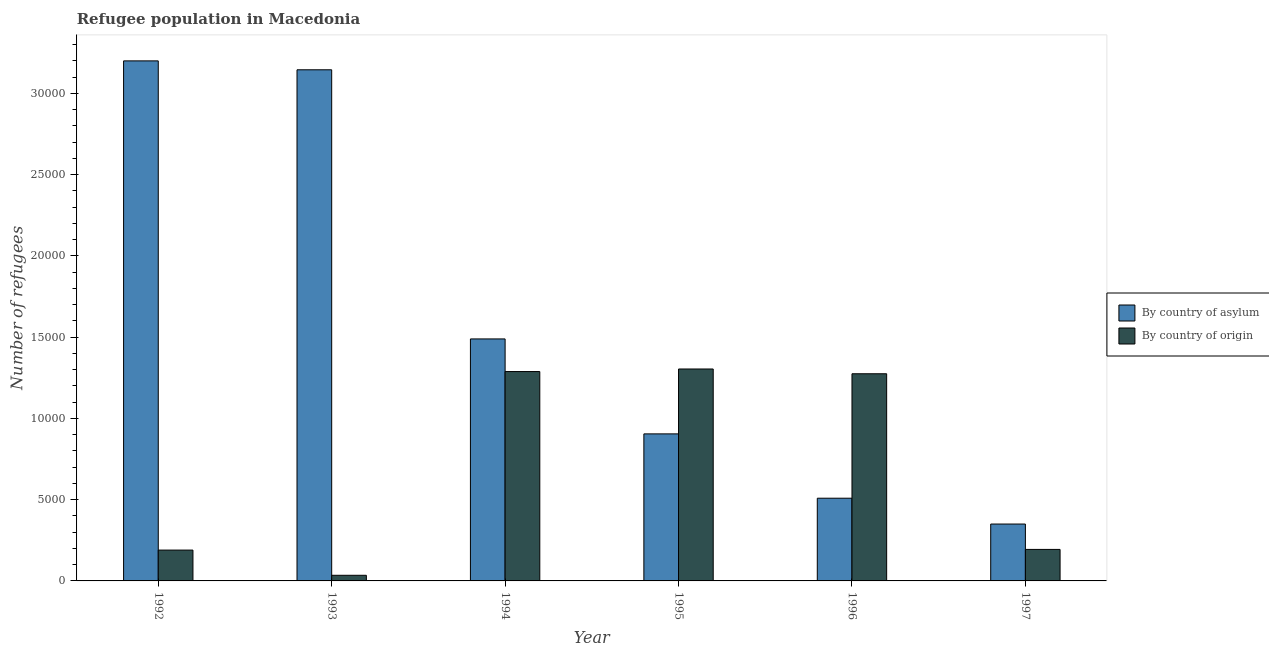How many groups of bars are there?
Ensure brevity in your answer.  6. How many bars are there on the 1st tick from the left?
Your response must be concise. 2. In how many cases, is the number of bars for a given year not equal to the number of legend labels?
Make the answer very short. 0. What is the number of refugees by country of asylum in 1997?
Your answer should be very brief. 3500. Across all years, what is the maximum number of refugees by country of asylum?
Your answer should be very brief. 3.20e+04. Across all years, what is the minimum number of refugees by country of asylum?
Your response must be concise. 3500. In which year was the number of refugees by country of origin maximum?
Your response must be concise. 1995. What is the total number of refugees by country of asylum in the graph?
Your answer should be very brief. 9.60e+04. What is the difference between the number of refugees by country of asylum in 1994 and that in 1995?
Make the answer very short. 5843. What is the difference between the number of refugees by country of origin in 1997 and the number of refugees by country of asylum in 1993?
Ensure brevity in your answer.  1592. What is the average number of refugees by country of asylum per year?
Ensure brevity in your answer.  1.60e+04. In the year 1994, what is the difference between the number of refugees by country of origin and number of refugees by country of asylum?
Make the answer very short. 0. What is the ratio of the number of refugees by country of asylum in 1992 to that in 1994?
Make the answer very short. 2.15. What is the difference between the highest and the second highest number of refugees by country of asylum?
Provide a short and direct response. 548. What is the difference between the highest and the lowest number of refugees by country of asylum?
Provide a short and direct response. 2.85e+04. In how many years, is the number of refugees by country of origin greater than the average number of refugees by country of origin taken over all years?
Your answer should be very brief. 3. Is the sum of the number of refugees by country of origin in 1992 and 1993 greater than the maximum number of refugees by country of asylum across all years?
Your response must be concise. No. What does the 1st bar from the left in 1993 represents?
Give a very brief answer. By country of asylum. What does the 2nd bar from the right in 1996 represents?
Offer a very short reply. By country of asylum. What is the difference between two consecutive major ticks on the Y-axis?
Your answer should be very brief. 5000. Are the values on the major ticks of Y-axis written in scientific E-notation?
Offer a terse response. No. Does the graph contain any zero values?
Your answer should be very brief. No. Does the graph contain grids?
Ensure brevity in your answer.  No. Where does the legend appear in the graph?
Provide a short and direct response. Center right. How many legend labels are there?
Provide a short and direct response. 2. What is the title of the graph?
Provide a short and direct response. Refugee population in Macedonia. What is the label or title of the X-axis?
Ensure brevity in your answer.  Year. What is the label or title of the Y-axis?
Give a very brief answer. Number of refugees. What is the Number of refugees in By country of asylum in 1992?
Keep it short and to the point. 3.20e+04. What is the Number of refugees in By country of origin in 1992?
Provide a short and direct response. 1897. What is the Number of refugees of By country of asylum in 1993?
Make the answer very short. 3.15e+04. What is the Number of refugees of By country of origin in 1993?
Provide a succinct answer. 347. What is the Number of refugees in By country of asylum in 1994?
Ensure brevity in your answer.  1.49e+04. What is the Number of refugees of By country of origin in 1994?
Ensure brevity in your answer.  1.29e+04. What is the Number of refugees in By country of asylum in 1995?
Ensure brevity in your answer.  9048. What is the Number of refugees of By country of origin in 1995?
Your answer should be very brief. 1.30e+04. What is the Number of refugees in By country of asylum in 1996?
Provide a short and direct response. 5089. What is the Number of refugees of By country of origin in 1996?
Offer a terse response. 1.27e+04. What is the Number of refugees of By country of asylum in 1997?
Your answer should be compact. 3500. What is the Number of refugees in By country of origin in 1997?
Provide a succinct answer. 1939. Across all years, what is the maximum Number of refugees of By country of asylum?
Make the answer very short. 3.20e+04. Across all years, what is the maximum Number of refugees of By country of origin?
Your answer should be compact. 1.30e+04. Across all years, what is the minimum Number of refugees of By country of asylum?
Offer a very short reply. 3500. Across all years, what is the minimum Number of refugees in By country of origin?
Keep it short and to the point. 347. What is the total Number of refugees in By country of asylum in the graph?
Your answer should be compact. 9.60e+04. What is the total Number of refugees in By country of origin in the graph?
Offer a very short reply. 4.29e+04. What is the difference between the Number of refugees in By country of asylum in 1992 and that in 1993?
Your response must be concise. 548. What is the difference between the Number of refugees in By country of origin in 1992 and that in 1993?
Ensure brevity in your answer.  1550. What is the difference between the Number of refugees of By country of asylum in 1992 and that in 1994?
Keep it short and to the point. 1.71e+04. What is the difference between the Number of refugees in By country of origin in 1992 and that in 1994?
Your answer should be very brief. -1.10e+04. What is the difference between the Number of refugees in By country of asylum in 1992 and that in 1995?
Keep it short and to the point. 2.30e+04. What is the difference between the Number of refugees of By country of origin in 1992 and that in 1995?
Make the answer very short. -1.11e+04. What is the difference between the Number of refugees in By country of asylum in 1992 and that in 1996?
Offer a terse response. 2.69e+04. What is the difference between the Number of refugees of By country of origin in 1992 and that in 1996?
Offer a terse response. -1.08e+04. What is the difference between the Number of refugees in By country of asylum in 1992 and that in 1997?
Offer a very short reply. 2.85e+04. What is the difference between the Number of refugees in By country of origin in 1992 and that in 1997?
Your answer should be compact. -42. What is the difference between the Number of refugees of By country of asylum in 1993 and that in 1994?
Offer a very short reply. 1.66e+04. What is the difference between the Number of refugees in By country of origin in 1993 and that in 1994?
Your response must be concise. -1.25e+04. What is the difference between the Number of refugees of By country of asylum in 1993 and that in 1995?
Give a very brief answer. 2.24e+04. What is the difference between the Number of refugees in By country of origin in 1993 and that in 1995?
Keep it short and to the point. -1.27e+04. What is the difference between the Number of refugees of By country of asylum in 1993 and that in 1996?
Your answer should be compact. 2.64e+04. What is the difference between the Number of refugees in By country of origin in 1993 and that in 1996?
Your response must be concise. -1.24e+04. What is the difference between the Number of refugees of By country of asylum in 1993 and that in 1997?
Give a very brief answer. 2.80e+04. What is the difference between the Number of refugees in By country of origin in 1993 and that in 1997?
Keep it short and to the point. -1592. What is the difference between the Number of refugees in By country of asylum in 1994 and that in 1995?
Offer a very short reply. 5843. What is the difference between the Number of refugees of By country of origin in 1994 and that in 1995?
Give a very brief answer. -158. What is the difference between the Number of refugees in By country of asylum in 1994 and that in 1996?
Keep it short and to the point. 9802. What is the difference between the Number of refugees of By country of origin in 1994 and that in 1996?
Offer a very short reply. 136. What is the difference between the Number of refugees in By country of asylum in 1994 and that in 1997?
Provide a succinct answer. 1.14e+04. What is the difference between the Number of refugees in By country of origin in 1994 and that in 1997?
Offer a very short reply. 1.09e+04. What is the difference between the Number of refugees of By country of asylum in 1995 and that in 1996?
Provide a short and direct response. 3959. What is the difference between the Number of refugees of By country of origin in 1995 and that in 1996?
Keep it short and to the point. 294. What is the difference between the Number of refugees in By country of asylum in 1995 and that in 1997?
Your response must be concise. 5548. What is the difference between the Number of refugees in By country of origin in 1995 and that in 1997?
Ensure brevity in your answer.  1.11e+04. What is the difference between the Number of refugees in By country of asylum in 1996 and that in 1997?
Make the answer very short. 1589. What is the difference between the Number of refugees in By country of origin in 1996 and that in 1997?
Make the answer very short. 1.08e+04. What is the difference between the Number of refugees of By country of asylum in 1992 and the Number of refugees of By country of origin in 1993?
Keep it short and to the point. 3.17e+04. What is the difference between the Number of refugees in By country of asylum in 1992 and the Number of refugees in By country of origin in 1994?
Give a very brief answer. 1.91e+04. What is the difference between the Number of refugees in By country of asylum in 1992 and the Number of refugees in By country of origin in 1995?
Ensure brevity in your answer.  1.90e+04. What is the difference between the Number of refugees in By country of asylum in 1992 and the Number of refugees in By country of origin in 1996?
Your response must be concise. 1.93e+04. What is the difference between the Number of refugees of By country of asylum in 1992 and the Number of refugees of By country of origin in 1997?
Provide a short and direct response. 3.01e+04. What is the difference between the Number of refugees of By country of asylum in 1993 and the Number of refugees of By country of origin in 1994?
Make the answer very short. 1.86e+04. What is the difference between the Number of refugees of By country of asylum in 1993 and the Number of refugees of By country of origin in 1995?
Provide a short and direct response. 1.84e+04. What is the difference between the Number of refugees in By country of asylum in 1993 and the Number of refugees in By country of origin in 1996?
Keep it short and to the point. 1.87e+04. What is the difference between the Number of refugees in By country of asylum in 1993 and the Number of refugees in By country of origin in 1997?
Your response must be concise. 2.95e+04. What is the difference between the Number of refugees in By country of asylum in 1994 and the Number of refugees in By country of origin in 1995?
Make the answer very short. 1850. What is the difference between the Number of refugees in By country of asylum in 1994 and the Number of refugees in By country of origin in 1996?
Ensure brevity in your answer.  2144. What is the difference between the Number of refugees of By country of asylum in 1994 and the Number of refugees of By country of origin in 1997?
Your answer should be compact. 1.30e+04. What is the difference between the Number of refugees in By country of asylum in 1995 and the Number of refugees in By country of origin in 1996?
Your response must be concise. -3699. What is the difference between the Number of refugees of By country of asylum in 1995 and the Number of refugees of By country of origin in 1997?
Ensure brevity in your answer.  7109. What is the difference between the Number of refugees of By country of asylum in 1996 and the Number of refugees of By country of origin in 1997?
Your answer should be compact. 3150. What is the average Number of refugees in By country of asylum per year?
Provide a succinct answer. 1.60e+04. What is the average Number of refugees of By country of origin per year?
Provide a short and direct response. 7142.33. In the year 1992, what is the difference between the Number of refugees in By country of asylum and Number of refugees in By country of origin?
Provide a short and direct response. 3.01e+04. In the year 1993, what is the difference between the Number of refugees of By country of asylum and Number of refugees of By country of origin?
Offer a very short reply. 3.11e+04. In the year 1994, what is the difference between the Number of refugees in By country of asylum and Number of refugees in By country of origin?
Provide a succinct answer. 2008. In the year 1995, what is the difference between the Number of refugees in By country of asylum and Number of refugees in By country of origin?
Make the answer very short. -3993. In the year 1996, what is the difference between the Number of refugees of By country of asylum and Number of refugees of By country of origin?
Keep it short and to the point. -7658. In the year 1997, what is the difference between the Number of refugees of By country of asylum and Number of refugees of By country of origin?
Ensure brevity in your answer.  1561. What is the ratio of the Number of refugees of By country of asylum in 1992 to that in 1993?
Your response must be concise. 1.02. What is the ratio of the Number of refugees of By country of origin in 1992 to that in 1993?
Offer a terse response. 5.47. What is the ratio of the Number of refugees of By country of asylum in 1992 to that in 1994?
Your answer should be compact. 2.15. What is the ratio of the Number of refugees in By country of origin in 1992 to that in 1994?
Give a very brief answer. 0.15. What is the ratio of the Number of refugees in By country of asylum in 1992 to that in 1995?
Your response must be concise. 3.54. What is the ratio of the Number of refugees of By country of origin in 1992 to that in 1995?
Provide a succinct answer. 0.15. What is the ratio of the Number of refugees of By country of asylum in 1992 to that in 1996?
Keep it short and to the point. 6.29. What is the ratio of the Number of refugees in By country of origin in 1992 to that in 1996?
Your answer should be very brief. 0.15. What is the ratio of the Number of refugees in By country of asylum in 1992 to that in 1997?
Your response must be concise. 9.14. What is the ratio of the Number of refugees of By country of origin in 1992 to that in 1997?
Provide a short and direct response. 0.98. What is the ratio of the Number of refugees of By country of asylum in 1993 to that in 1994?
Provide a succinct answer. 2.11. What is the ratio of the Number of refugees in By country of origin in 1993 to that in 1994?
Your answer should be compact. 0.03. What is the ratio of the Number of refugees in By country of asylum in 1993 to that in 1995?
Keep it short and to the point. 3.48. What is the ratio of the Number of refugees in By country of origin in 1993 to that in 1995?
Give a very brief answer. 0.03. What is the ratio of the Number of refugees in By country of asylum in 1993 to that in 1996?
Offer a very short reply. 6.18. What is the ratio of the Number of refugees in By country of origin in 1993 to that in 1996?
Provide a succinct answer. 0.03. What is the ratio of the Number of refugees of By country of asylum in 1993 to that in 1997?
Provide a succinct answer. 8.99. What is the ratio of the Number of refugees of By country of origin in 1993 to that in 1997?
Give a very brief answer. 0.18. What is the ratio of the Number of refugees of By country of asylum in 1994 to that in 1995?
Keep it short and to the point. 1.65. What is the ratio of the Number of refugees in By country of origin in 1994 to that in 1995?
Offer a very short reply. 0.99. What is the ratio of the Number of refugees in By country of asylum in 1994 to that in 1996?
Your answer should be compact. 2.93. What is the ratio of the Number of refugees of By country of origin in 1994 to that in 1996?
Make the answer very short. 1.01. What is the ratio of the Number of refugees of By country of asylum in 1994 to that in 1997?
Offer a terse response. 4.25. What is the ratio of the Number of refugees in By country of origin in 1994 to that in 1997?
Provide a succinct answer. 6.64. What is the ratio of the Number of refugees in By country of asylum in 1995 to that in 1996?
Provide a succinct answer. 1.78. What is the ratio of the Number of refugees of By country of origin in 1995 to that in 1996?
Provide a succinct answer. 1.02. What is the ratio of the Number of refugees of By country of asylum in 1995 to that in 1997?
Offer a very short reply. 2.59. What is the ratio of the Number of refugees of By country of origin in 1995 to that in 1997?
Your answer should be very brief. 6.73. What is the ratio of the Number of refugees in By country of asylum in 1996 to that in 1997?
Offer a terse response. 1.45. What is the ratio of the Number of refugees of By country of origin in 1996 to that in 1997?
Ensure brevity in your answer.  6.57. What is the difference between the highest and the second highest Number of refugees in By country of asylum?
Offer a terse response. 548. What is the difference between the highest and the second highest Number of refugees in By country of origin?
Your response must be concise. 158. What is the difference between the highest and the lowest Number of refugees in By country of asylum?
Your response must be concise. 2.85e+04. What is the difference between the highest and the lowest Number of refugees of By country of origin?
Provide a succinct answer. 1.27e+04. 